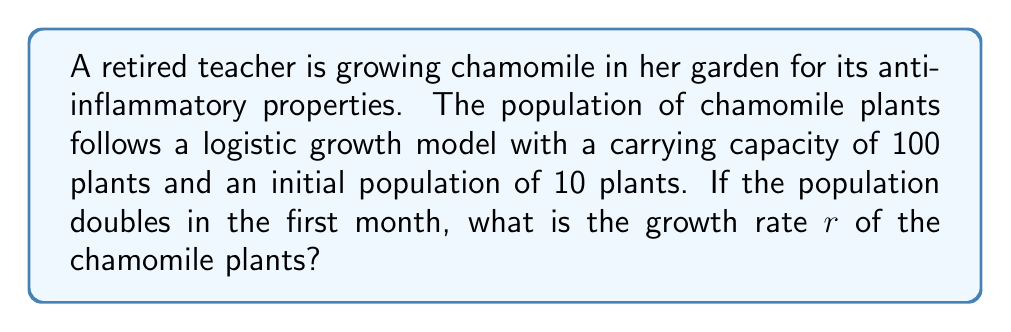Help me with this question. Let's approach this step-by-step using the logistic growth model:

1) The logistic growth model is given by the equation:

   $$N(t) = \frac{K}{1 + (\frac{K}{N_0} - 1)e^{-rt}}$$

   where:
   $N(t)$ is the population at time $t$
   $K$ is the carrying capacity
   $N_0$ is the initial population
   $r$ is the growth rate

2) We know:
   $K = 100$ (carrying capacity)
   $N_0 = 10$ (initial population)
   $N(1) = 20$ (population after one month, which is double the initial)
   $t = 1$ (time in months)

3) Let's substitute these values into the equation:

   $$20 = \frac{100}{1 + (\frac{100}{10} - 1)e^{-r(1)}}$$

4) Simplify:

   $$20 = \frac{100}{1 + 9e^{-r}}$$

5) Multiply both sides by $(1 + 9e^{-r})$:

   $$20(1 + 9e^{-r}) = 100$$

6) Expand:

   $$20 + 180e^{-r} = 100$$

7) Subtract 20 from both sides:

   $$180e^{-r} = 80$$

8) Divide both sides by 180:

   $$e^{-r} = \frac{4}{9}$$

9) Take the natural log of both sides:

   $$-r = \ln(\frac{4}{9})$$

10) Solve for r:

    $$r = -\ln(\frac{4}{9}) = \ln(\frac{9}{4}) \approx 0.8109$$
Answer: $r = \ln(\frac{9}{4}) \approx 0.8109$ per month 